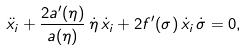Convert formula to latex. <formula><loc_0><loc_0><loc_500><loc_500>\ddot { x } _ { i } + \frac { 2 a ^ { \prime } ( \eta ) } { a ( \eta ) } \, \dot { \eta } \, \dot { x } _ { i } + 2 f ^ { \prime } ( \sigma ) \, \dot { x } _ { i } \, \dot { \sigma } = 0 ,</formula> 